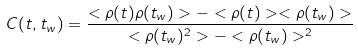<formula> <loc_0><loc_0><loc_500><loc_500>C ( t , t _ { w } ) = \frac { < \rho ( t ) \rho ( t _ { w } ) > - < \rho ( t ) > < \rho ( t _ { w } ) > } { < \rho ( t _ { w } ) ^ { 2 } > - < \rho ( t _ { w } ) > ^ { 2 } }</formula> 